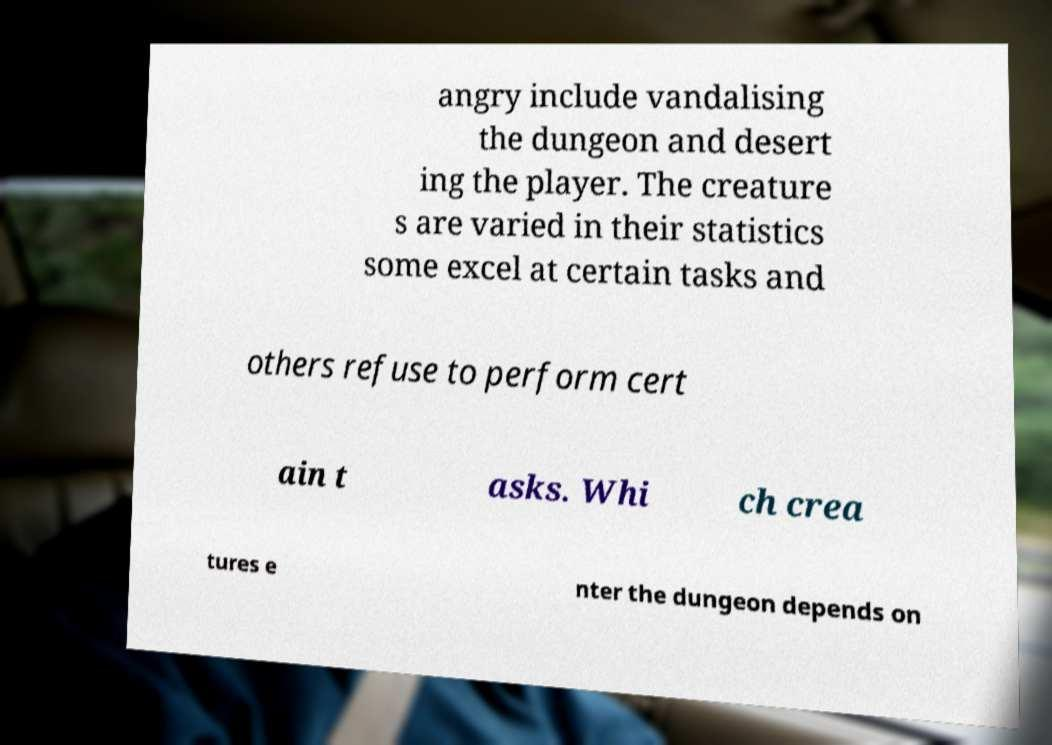I need the written content from this picture converted into text. Can you do that? angry include vandalising the dungeon and desert ing the player. The creature s are varied in their statistics some excel at certain tasks and others refuse to perform cert ain t asks. Whi ch crea tures e nter the dungeon depends on 